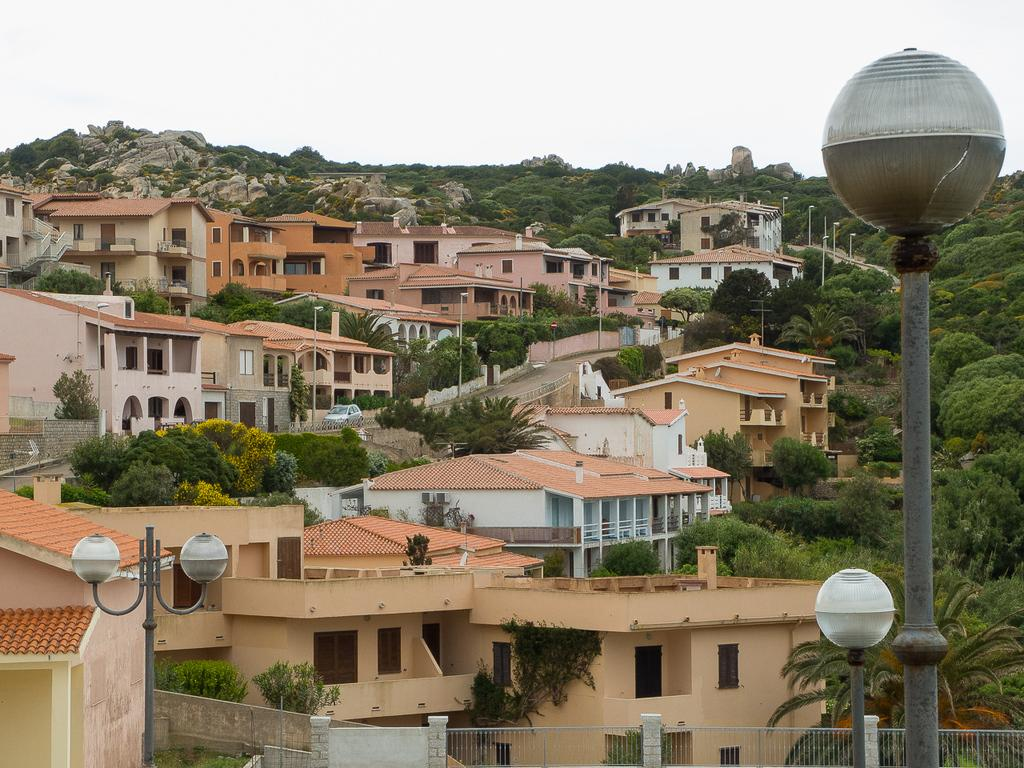What can be seen at the bottom of the image? There is a fence and poles at the bottom of the image. What is visible in the background of the image? There are houses, buildings, windows, a vehicle, trees, poles, rocks, and the sky visible in the background of the image. What type of secretary can be seen working in the image? There is no secretary present in the image. What role does the wind play in the image? The wind is not mentioned or depicted in the image. 